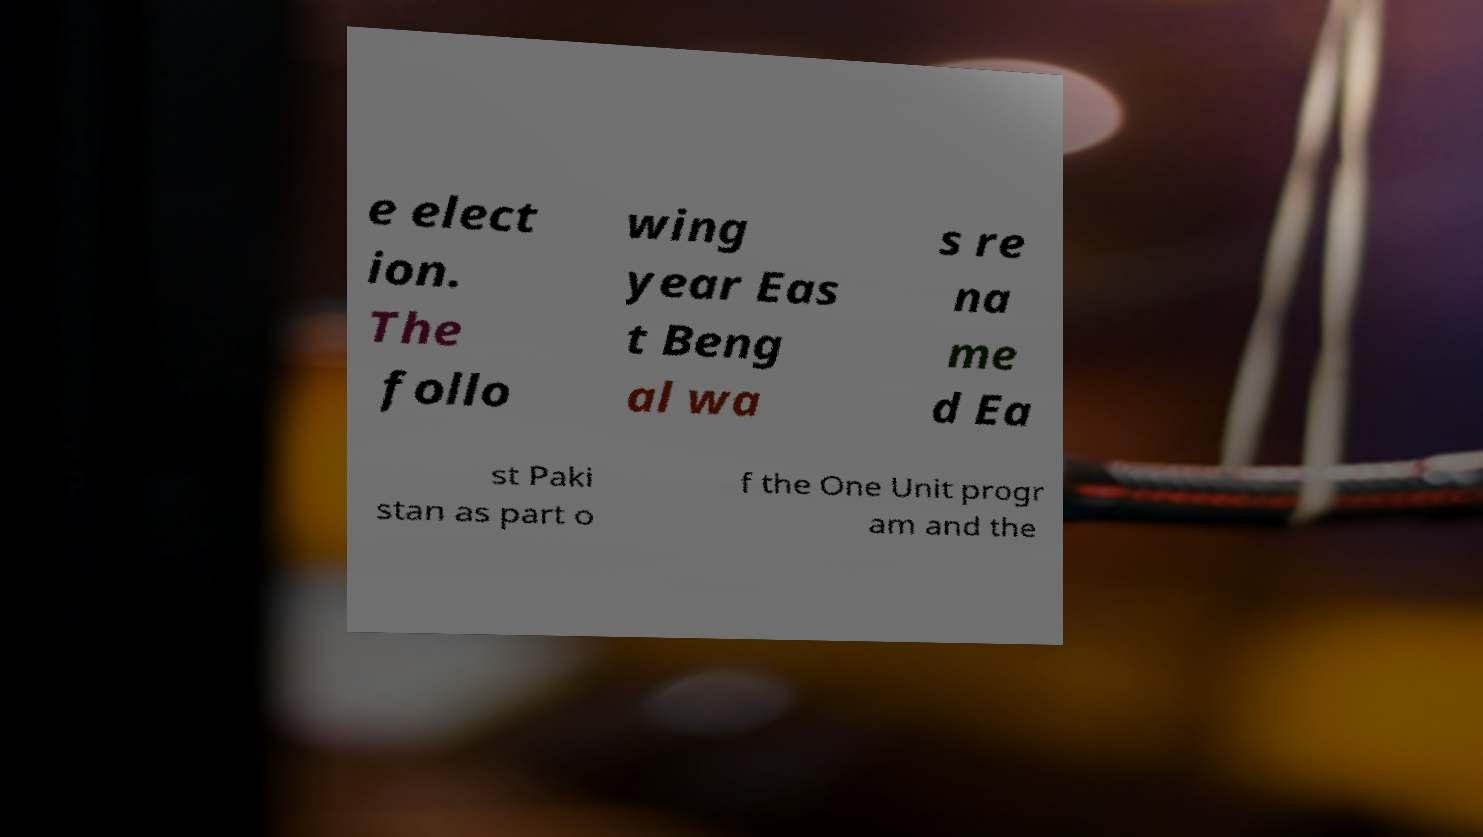I need the written content from this picture converted into text. Can you do that? e elect ion. The follo wing year Eas t Beng al wa s re na me d Ea st Paki stan as part o f the One Unit progr am and the 